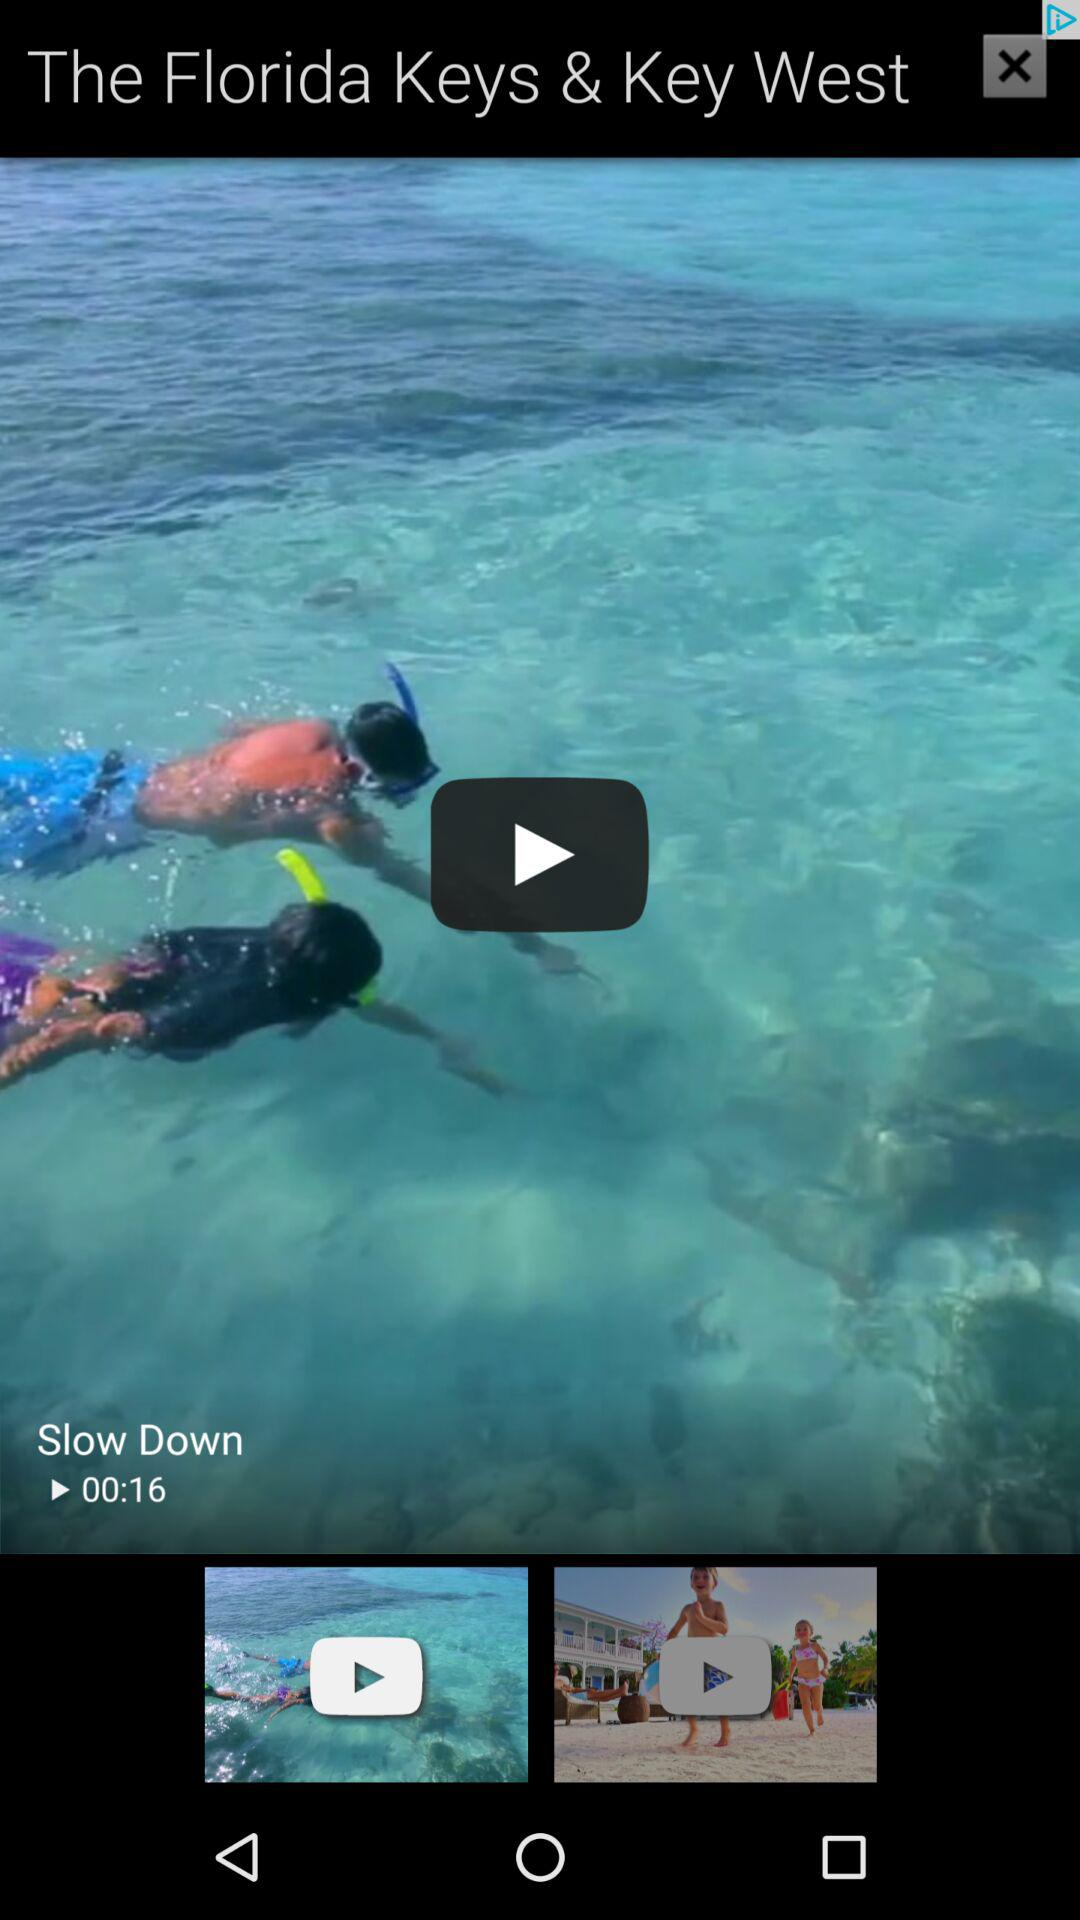What is the length of the video? The length of the video is 16 seconds. 